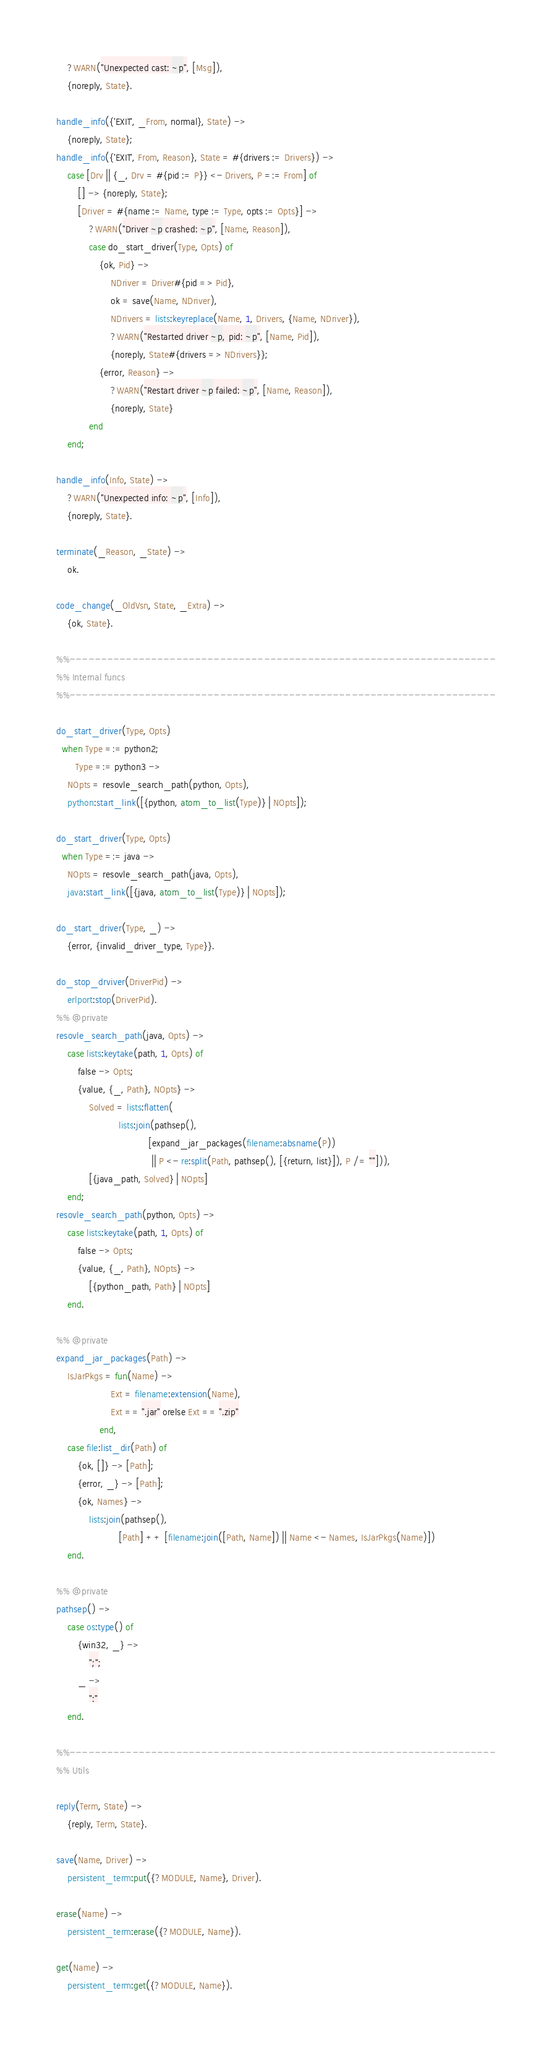<code> <loc_0><loc_0><loc_500><loc_500><_Erlang_>    ?WARN("Unexpected cast: ~p", [Msg]),
    {noreply, State}.

handle_info({'EXIT', _From, normal}, State) ->
    {noreply, State};
handle_info({'EXIT', From, Reason}, State = #{drivers := Drivers}) ->
    case [Drv || {_, Drv = #{pid := P}} <- Drivers, P =:= From] of
        [] -> {noreply, State};
        [Driver = #{name := Name, type := Type, opts := Opts}] ->
            ?WARN("Driver ~p crashed: ~p", [Name, Reason]),
            case do_start_driver(Type, Opts) of
                {ok, Pid} ->
                    NDriver = Driver#{pid => Pid},
                    ok = save(Name, NDriver),
                    NDrivers = lists:keyreplace(Name, 1, Drivers, {Name, NDriver}),
                    ?WARN("Restarted driver ~p, pid: ~p", [Name, Pid]),
                    {noreply, State#{drivers => NDrivers}};
                {error, Reason} ->
                    ?WARN("Restart driver ~p failed: ~p", [Name, Reason]),
                    {noreply, State}
            end
    end;

handle_info(Info, State) ->
    ?WARN("Unexpected info: ~p", [Info]),
    {noreply, State}.

terminate(_Reason, _State) ->
    ok.

code_change(_OldVsn, State, _Extra) ->
    {ok, State}.

%%--------------------------------------------------------------------
%% Internal funcs
%%--------------------------------------------------------------------

do_start_driver(Type, Opts)
  when Type =:= python2;
       Type =:= python3 ->
    NOpts = resovle_search_path(python, Opts),
    python:start_link([{python, atom_to_list(Type)} | NOpts]);

do_start_driver(Type, Opts)
  when Type =:= java ->
    NOpts = resovle_search_path(java, Opts),
    java:start_link([{java, atom_to_list(Type)} | NOpts]);

do_start_driver(Type, _) ->
    {error, {invalid_driver_type, Type}}.

do_stop_drviver(DriverPid) ->
    erlport:stop(DriverPid).
%% @private
resovle_search_path(java, Opts) ->
    case lists:keytake(path, 1, Opts) of
        false -> Opts;
        {value, {_, Path}, NOpts} ->
            Solved = lists:flatten(
                       lists:join(pathsep(),
                                  [expand_jar_packages(filename:absname(P))
                                   || P <- re:split(Path, pathsep(), [{return, list}]), P /= ""])),
            [{java_path, Solved} | NOpts]
    end;
resovle_search_path(python, Opts) ->
    case lists:keytake(path, 1, Opts) of
        false -> Opts;
        {value, {_, Path}, NOpts} ->
            [{python_path, Path} | NOpts]
    end.

%% @private
expand_jar_packages(Path) ->
    IsJarPkgs = fun(Name) ->
                    Ext = filename:extension(Name),
                    Ext == ".jar" orelse Ext == ".zip"
                end,
    case file:list_dir(Path) of
        {ok, []} -> [Path];
        {error, _} -> [Path];
        {ok, Names} ->
            lists:join(pathsep(),
                       [Path] ++ [filename:join([Path, Name]) || Name <- Names, IsJarPkgs(Name)])
    end.

%% @private
pathsep() ->
    case os:type() of
        {win32, _} ->
            ";";
        _ ->
            ":"
    end.

%%--------------------------------------------------------------------
%% Utils

reply(Term, State) ->
    {reply, Term, State}.

save(Name, Driver) ->
    persistent_term:put({?MODULE, Name}, Driver).

erase(Name) ->
    persistent_term:erase({?MODULE, Name}).

get(Name) ->
    persistent_term:get({?MODULE, Name}).
</code> 